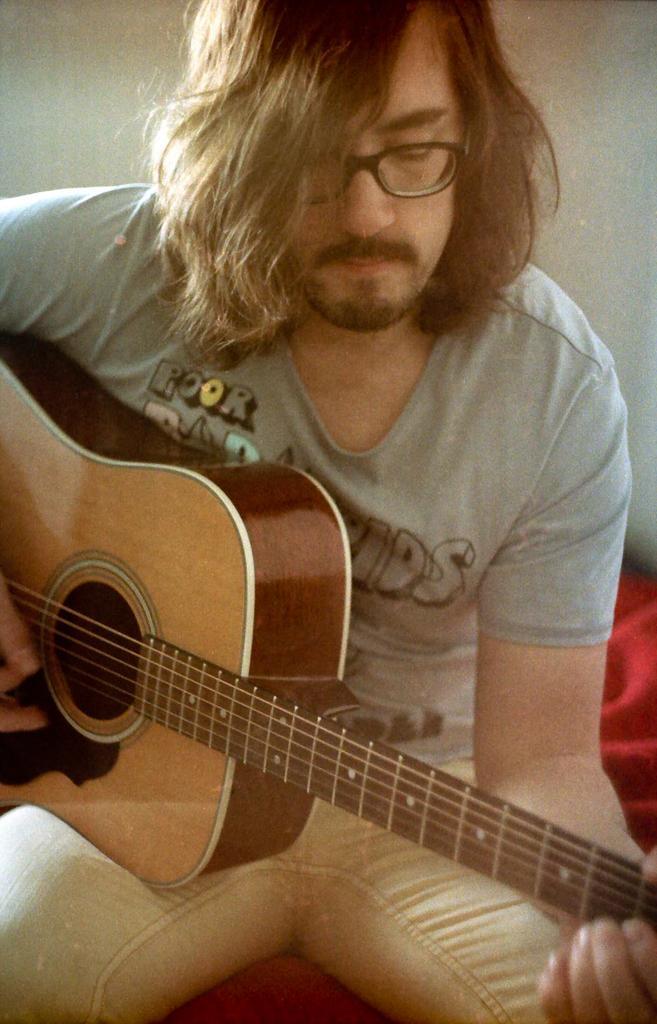Can you describe this image briefly? In this we can see a person a playing a guitar. 